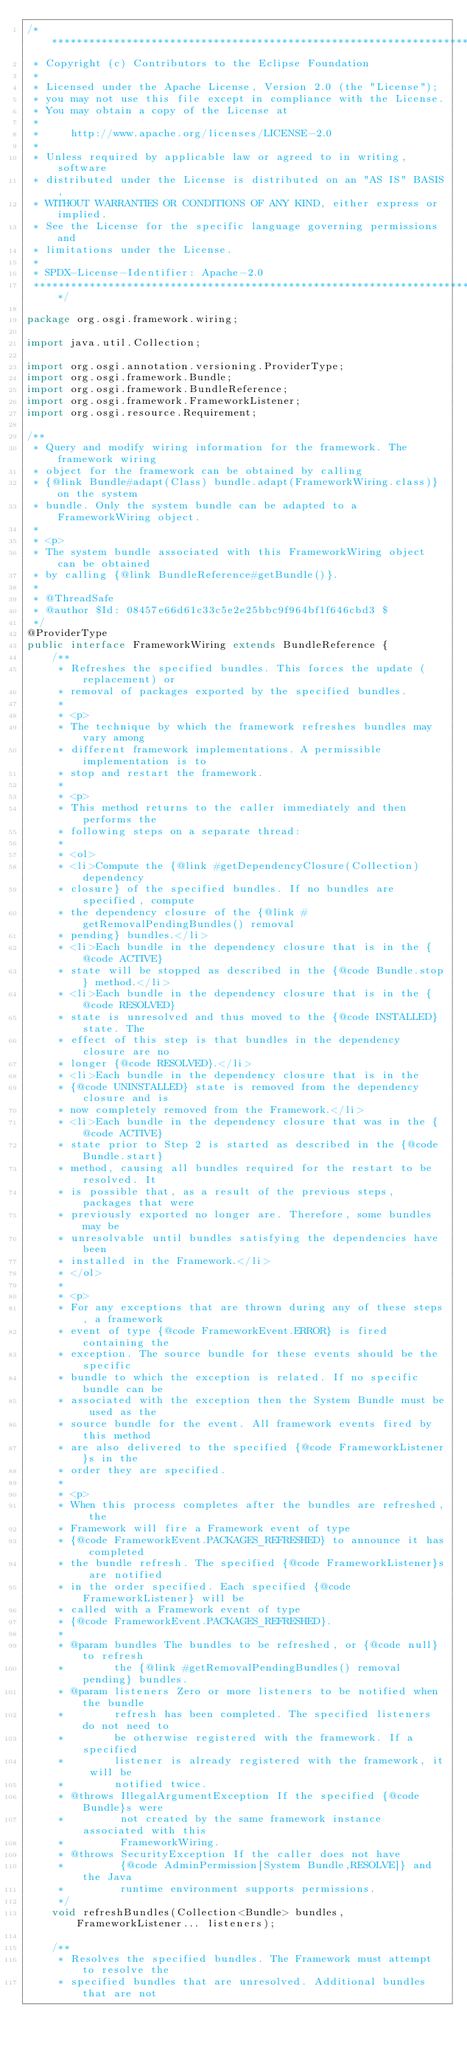<code> <loc_0><loc_0><loc_500><loc_500><_Java_>/*******************************************************************************
 * Copyright (c) Contributors to the Eclipse Foundation
 *
 * Licensed under the Apache License, Version 2.0 (the "License");
 * you may not use this file except in compliance with the License.
 * You may obtain a copy of the License at
 *
 *     http://www.apache.org/licenses/LICENSE-2.0
 *
 * Unless required by applicable law or agreed to in writing, software
 * distributed under the License is distributed on an "AS IS" BASIS,
 * WITHOUT WARRANTIES OR CONDITIONS OF ANY KIND, either express or implied.
 * See the License for the specific language governing permissions and
 * limitations under the License.
 *
 * SPDX-License-Identifier: Apache-2.0 
 *******************************************************************************/

package org.osgi.framework.wiring;

import java.util.Collection;

import org.osgi.annotation.versioning.ProviderType;
import org.osgi.framework.Bundle;
import org.osgi.framework.BundleReference;
import org.osgi.framework.FrameworkListener;
import org.osgi.resource.Requirement;

/**
 * Query and modify wiring information for the framework. The framework wiring
 * object for the framework can be obtained by calling
 * {@link Bundle#adapt(Class) bundle.adapt(FrameworkWiring.class)} on the system
 * bundle. Only the system bundle can be adapted to a FrameworkWiring object.
 * 
 * <p>
 * The system bundle associated with this FrameworkWiring object can be obtained
 * by calling {@link BundleReference#getBundle()}.
 * 
 * @ThreadSafe
 * @author $Id: 08457e66d61c33c5e2e25bbc9f964bf1f646cbd3 $
 */
@ProviderType
public interface FrameworkWiring extends BundleReference {
	/**
	 * Refreshes the specified bundles. This forces the update (replacement) or
	 * removal of packages exported by the specified bundles.
	 * 
	 * <p>
	 * The technique by which the framework refreshes bundles may vary among
	 * different framework implementations. A permissible implementation is to
	 * stop and restart the framework.
	 * 
	 * <p>
	 * This method returns to the caller immediately and then performs the
	 * following steps on a separate thread:
	 * 
	 * <ol>
	 * <li>Compute the {@link #getDependencyClosure(Collection) dependency
	 * closure} of the specified bundles. If no bundles are specified, compute
	 * the dependency closure of the {@link #getRemovalPendingBundles() removal
	 * pending} bundles.</li>
	 * <li>Each bundle in the dependency closure that is in the {@code ACTIVE}
	 * state will be stopped as described in the {@code Bundle.stop} method.</li>
	 * <li>Each bundle in the dependency closure that is in the {@code RESOLVED}
	 * state is unresolved and thus moved to the {@code INSTALLED} state. The
	 * effect of this step is that bundles in the dependency closure are no
	 * longer {@code RESOLVED}.</li>
	 * <li>Each bundle in the dependency closure that is in the
	 * {@code UNINSTALLED} state is removed from the dependency closure and is
	 * now completely removed from the Framework.</li>
	 * <li>Each bundle in the dependency closure that was in the {@code ACTIVE}
	 * state prior to Step 2 is started as described in the {@code Bundle.start}
	 * method, causing all bundles required for the restart to be resolved. It
	 * is possible that, as a result of the previous steps, packages that were
	 * previously exported no longer are. Therefore, some bundles may be
	 * unresolvable until bundles satisfying the dependencies have been
	 * installed in the Framework.</li>
	 * </ol>
	 * 
	 * <p>
	 * For any exceptions that are thrown during any of these steps, a framework
	 * event of type {@code FrameworkEvent.ERROR} is fired containing the
	 * exception. The source bundle for these events should be the specific
	 * bundle to which the exception is related. If no specific bundle can be
	 * associated with the exception then the System Bundle must be used as the
	 * source bundle for the event. All framework events fired by this method
	 * are also delivered to the specified {@code FrameworkListener}s in the
	 * order they are specified.
	 * 
	 * <p>
	 * When this process completes after the bundles are refreshed, the
	 * Framework will fire a Framework event of type
	 * {@code FrameworkEvent.PACKAGES_REFRESHED} to announce it has completed
	 * the bundle refresh. The specified {@code FrameworkListener}s are notified
	 * in the order specified. Each specified {@code FrameworkListener} will be
	 * called with a Framework event of type
	 * {@code FrameworkEvent.PACKAGES_REFRESHED}.
	 * 
	 * @param bundles The bundles to be refreshed, or {@code null} to refresh
	 *        the {@link #getRemovalPendingBundles() removal pending} bundles.
	 * @param listeners Zero or more listeners to be notified when the bundle
	 *        refresh has been completed. The specified listeners do not need to
	 *        be otherwise registered with the framework. If a specified
	 *        listener is already registered with the framework, it will be
	 *        notified twice.
	 * @throws IllegalArgumentException If the specified {@code Bundle}s were
	 *         not created by the same framework instance associated with this
	 *         FrameworkWiring.
	 * @throws SecurityException If the caller does not have
	 *         {@code AdminPermission[System Bundle,RESOLVE]} and the Java
	 *         runtime environment supports permissions.
	 */
	void refreshBundles(Collection<Bundle> bundles, FrameworkListener... listeners);

	/**
	 * Resolves the specified bundles. The Framework must attempt to resolve the
	 * specified bundles that are unresolved. Additional bundles that are not</code> 